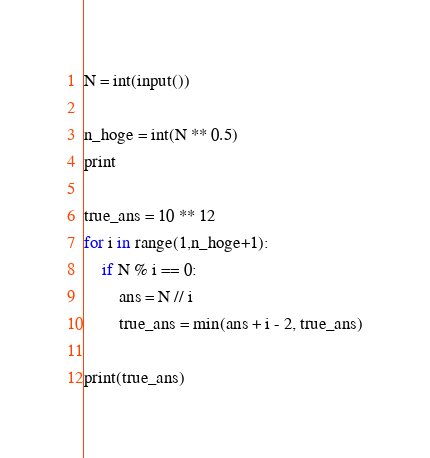Convert code to text. <code><loc_0><loc_0><loc_500><loc_500><_Python_>N = int(input())

n_hoge = int(N ** 0.5)
print

true_ans = 10 ** 12
for i in range(1,n_hoge+1):
    if N % i == 0:
        ans = N // i
        true_ans = min(ans + i - 2, true_ans)

print(true_ans)</code> 